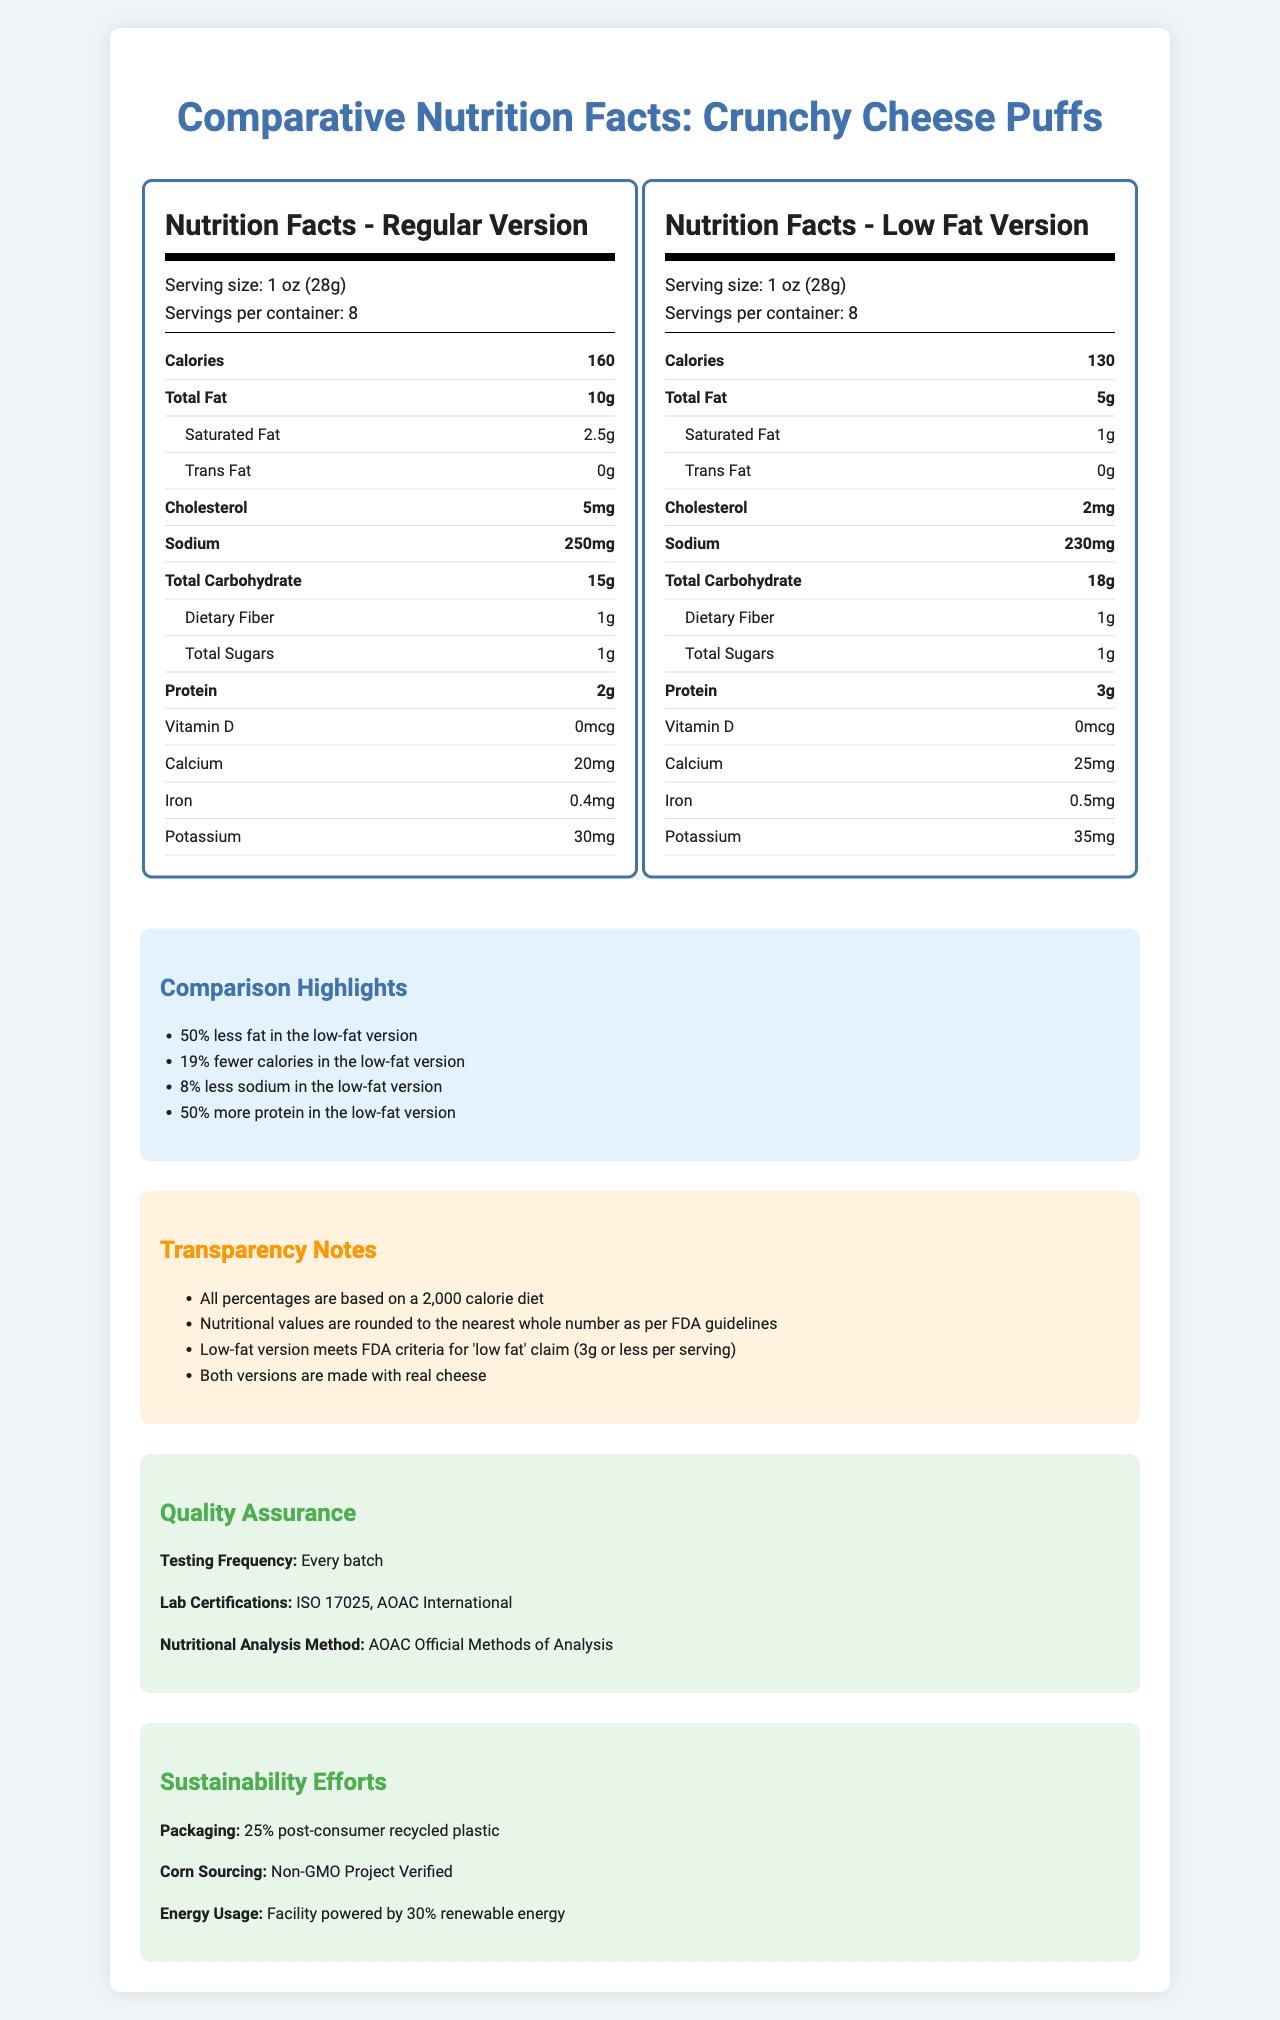What is the serving size for both versions of Crunchy Cheese Puffs? The serving size information is listed under the "serving-info" section for both versions.
Answer: 1 oz (28g) How many calories are in the regular version? The calorie count for the regular version is highlighted under the calories section of the nutrition label.
Answer: 160 What is the total fat content in the low-fat version? The total fat content for the low-fat version can be found in the "Total Fat" row of its nutrition label.
Answer: 5g How much protein does the low-fat version contain? The protein content for the low-fat version is displayed in the "Protein" row of its nutrition label.
Answer: 3g Which version contains more sodium? The regular version has 250 mg of sodium, while the low-fat version has 230 mg, as shown in their respective "Sodium" rows.
Answer: Regular Version How much saturated fat is in the regular version? The saturated fat content for the regular version is listed under the "Saturated Fat" row in its nutrition label.
Answer: 2.5g What is the iron content in the low-fat version? The iron content for the low-fat version is provided in the "Iron" row of its nutrition label.
Answer: 0.5mg Which version has more potassium? 
A. Regular Version
B. Low-fat Version
C. Both have the same potassium content The low-fat version contains 35 mg of potassium compared to the regular version's 30 mg.
Answer: B What is the difference in cholesterol between the two versions? 
1. 1mg
2. 3mg
3. 5mg
4. 7mg The regular version has 5 mg of cholesterol, while the low-fat version has 2 mg, resulting in a difference of 3 mg.
Answer: 3 Can you determine if the facility that manufactures Crunchy Cheese Puffs only processes cheese snacks? The document states that the facility also processes peanuts and tree nuts, so it does not only process cheese snacks.
Answer: No Is it true that the low-fat version of Crunchy Cheese Puffs meets the FDA criteria for a 'low-fat' claim? The transparency notes section confirms that the low-fat version meets the FDA criteria for a 'low-fat' claim (3g or less per serving).
Answer: Yes Summarize the main differences between the regular and low-fat versions of Crunchy Cheese Puffs. The document compares the nutritional facts of the regular and low-fat versions side-by-side, highlighting how the low-fat version is improved in various aspects.
Answer: The main differences include lower calories, lower total fat, lower saturated fat, lower cholesterol, lower sodium, higher carbohydrates, higher protein, higher calcium, higher iron, and higher potassium in the low-fat version. Additionally, the low-fat version meets the FDA criteria for a 'low-fat' claim. What allergens are present in Crunchy Cheese Puffs? The allergen information section lists that the product contains milk.
Answer: Milk How is the protein content different between the two versions? According to the comparison highlights, the low-fat version contains 50% more protein than the regular version.
Answer: The low-fat version has 50% more protein 